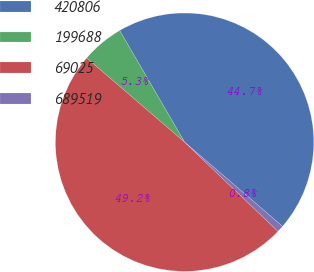Convert chart to OTSL. <chart><loc_0><loc_0><loc_500><loc_500><pie_chart><fcel>420806<fcel>199688<fcel>69025<fcel>689519<nl><fcel>44.68%<fcel>5.32%<fcel>49.16%<fcel>0.84%<nl></chart> 